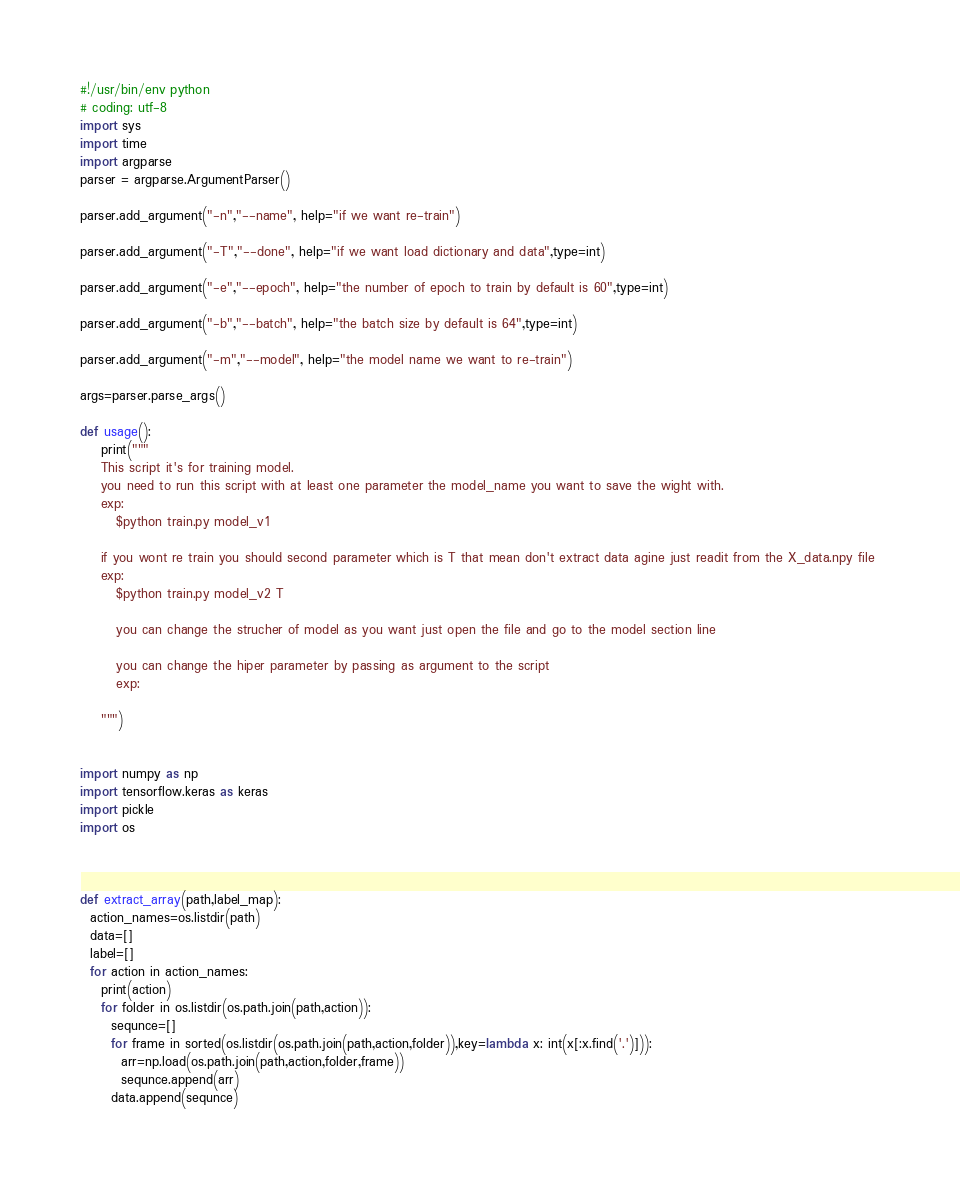<code> <loc_0><loc_0><loc_500><loc_500><_Python_>#!/usr/bin/env python
# coding: utf-8
import sys
import time
import argparse
parser = argparse.ArgumentParser()

parser.add_argument("-n","--name", help="if we want re-train")

parser.add_argument("-T","--done", help="if we want load dictionary and data",type=int)

parser.add_argument("-e","--epoch", help="the number of epoch to train by default is 60",type=int)

parser.add_argument("-b","--batch", help="the batch size by default is 64",type=int)

parser.add_argument("-m","--model", help="the model name we want to re-train")

args=parser.parse_args()
	
def usage():
    print("""
    This script it's for training model.
    you need to run this script with at least one parameter the model_name you want to save the wight with.
    exp:
       $python train.py model_v1
    
    if you wont re train you should second parameter which is T that mean don't extract data agine just readit from the X_data.npy file 
    exp:
       $python train.py model_v2 T
       
       you can change the strucher of model as you want just open the file and go to the model section line 
       
       you can change the hiper parameter by passing as argument to the script
       exp:
       	
    """)
	

import numpy as np
import tensorflow.keras as keras
import pickle
import os 



def extract_array(path,label_map):
  action_names=os.listdir(path)
  data=[]
  label=[]
  for action in action_names:
    print(action)
    for folder in os.listdir(os.path.join(path,action)):
      sequnce=[]
      for frame in sorted(os.listdir(os.path.join(path,action,folder)),key=lambda x: int(x[:x.find('.')])):
        arr=np.load(os.path.join(path,action,folder,frame))
        sequnce.append(arr)
      data.append(sequnce)</code> 